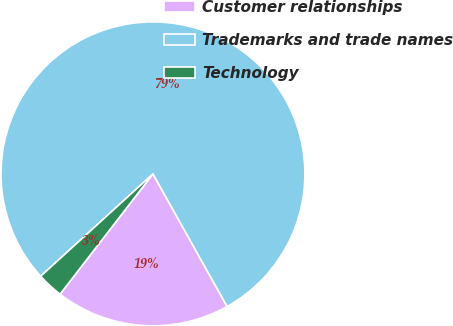Convert chart. <chart><loc_0><loc_0><loc_500><loc_500><pie_chart><fcel>Customer relationships<fcel>Trademarks and trade names<fcel>Technology<nl><fcel>18.58%<fcel>78.65%<fcel>2.77%<nl></chart> 